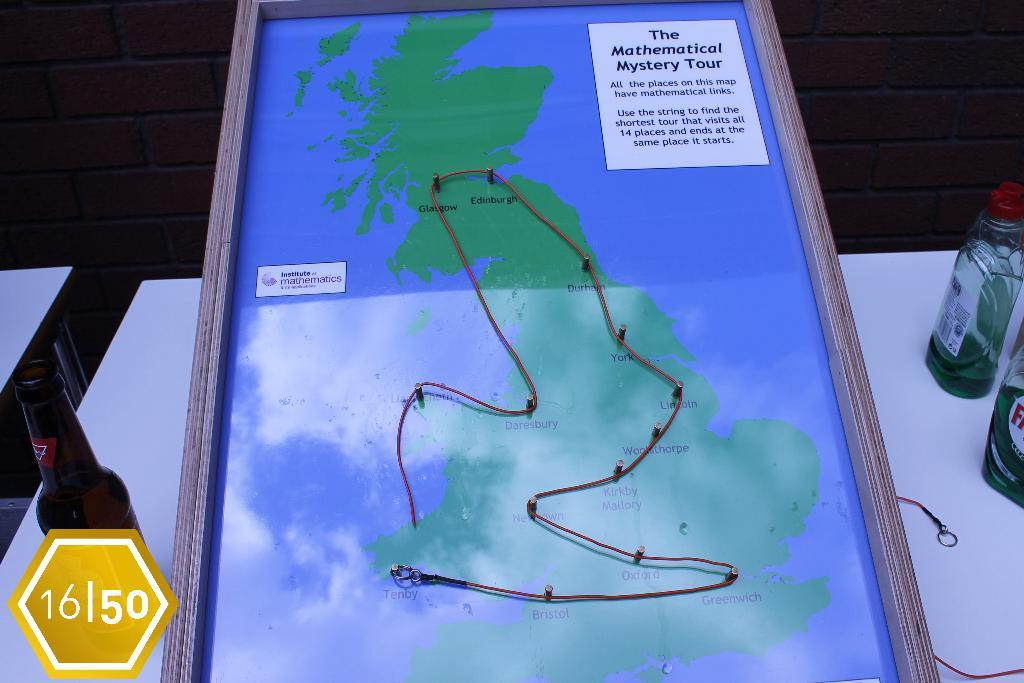<image>
Summarize the visual content of the image. A map titled the Mathematical mystery tour with string on it 